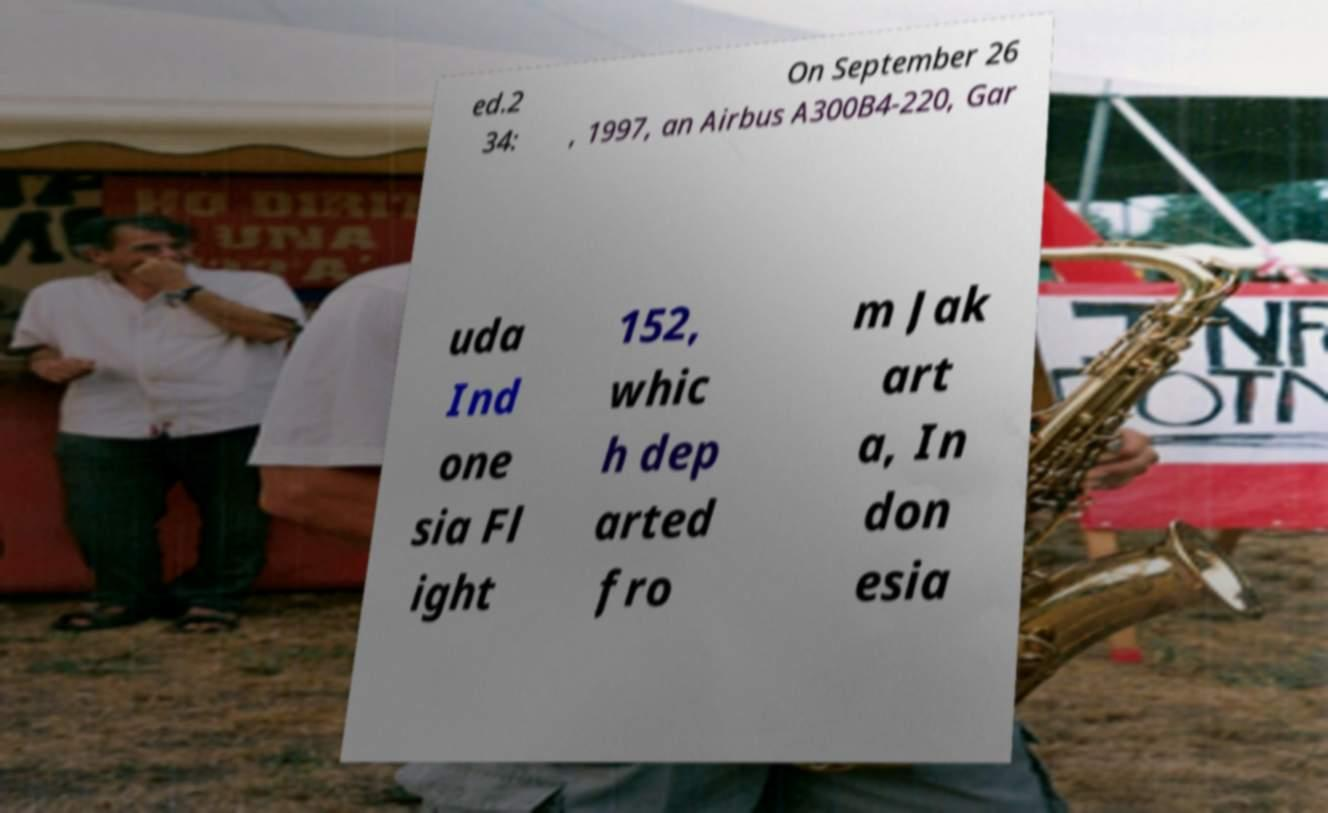Can you read and provide the text displayed in the image?This photo seems to have some interesting text. Can you extract and type it out for me? ed.2 34: On September 26 , 1997, an Airbus A300B4-220, Gar uda Ind one sia Fl ight 152, whic h dep arted fro m Jak art a, In don esia 